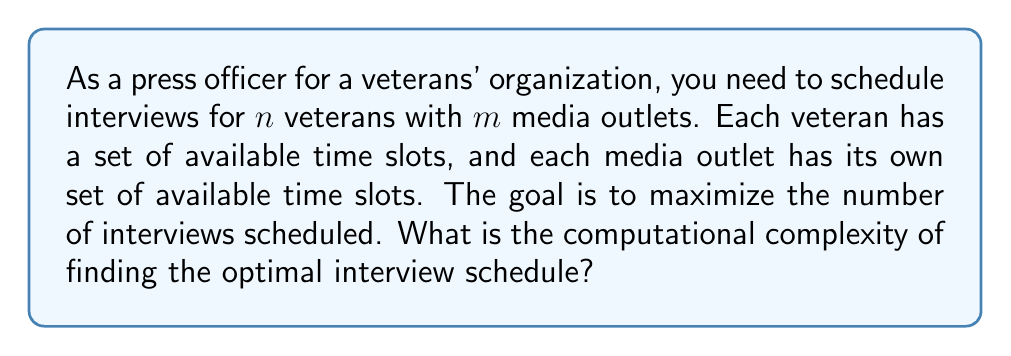Help me with this question. To determine the computational complexity of this problem, we need to analyze it in terms of known problems in complexity theory:

1. Problem formulation:
   - We have $n$ veterans and $m$ media outlets
   - Each veteran and media outlet has a set of available time slots
   - We want to maximize the number of scheduled interviews

2. Mapping to a known problem:
   This problem can be mapped to the Maximum Bipartite Matching problem:
   - Veterans and media outlets form the two sets of vertices in a bipartite graph
   - An edge exists between a veteran and a media outlet if they have a common available time slot
   - Finding the maximum number of interviews is equivalent to finding the maximum matching in this bipartite graph

3. Complexity of Maximum Bipartite Matching:
   - The best known algorithm for solving Maximum Bipartite Matching is the Hopcroft-Karp algorithm
   - Time complexity of Hopcroft-Karp: $O(E\sqrt{V})$, where $E$ is the number of edges and $V$ is the number of vertices

4. Analysis for our specific problem:
   - Number of vertices: $V = n + m$ (veterans + media outlets)
   - Maximum number of edges: $E = nm$ (if all veterans could potentially interview with all media outlets)
   - Substituting into the Hopcroft-Karp complexity: $O(nm\sqrt{n+m})$

5. Simplification:
   - Assuming $n$ and $m$ are of similar magnitude, we can express this as $O(n^{2.5})$, where $n$ represents the larger of the two values

Therefore, the computational complexity of finding the optimal interview schedule is $O(n^{2.5})$, where $n$ is the larger of the number of veterans or media outlets.
Answer: The computational complexity of finding the optimal interview schedule is $O(n^{2.5})$, where $n$ is the larger of the number of veterans or media outlets. 